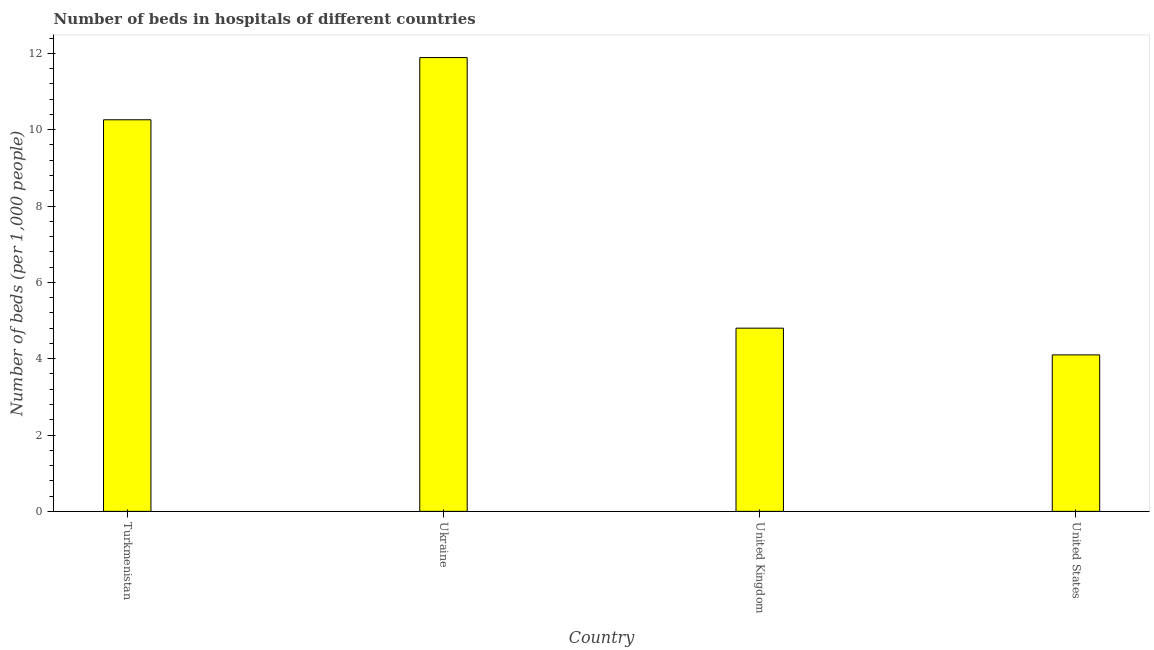Does the graph contain any zero values?
Offer a terse response. No. Does the graph contain grids?
Make the answer very short. No. What is the title of the graph?
Offer a terse response. Number of beds in hospitals of different countries. What is the label or title of the X-axis?
Ensure brevity in your answer.  Country. What is the label or title of the Y-axis?
Offer a very short reply. Number of beds (per 1,0 people). What is the number of hospital beds in United States?
Your answer should be very brief. 4.1. Across all countries, what is the maximum number of hospital beds?
Ensure brevity in your answer.  11.89. Across all countries, what is the minimum number of hospital beds?
Your response must be concise. 4.1. In which country was the number of hospital beds maximum?
Your answer should be compact. Ukraine. In which country was the number of hospital beds minimum?
Your answer should be very brief. United States. What is the sum of the number of hospital beds?
Give a very brief answer. 31.05. What is the difference between the number of hospital beds in Ukraine and United States?
Offer a very short reply. 7.79. What is the average number of hospital beds per country?
Your answer should be compact. 7.76. What is the median number of hospital beds?
Your answer should be compact. 7.53. In how many countries, is the number of hospital beds greater than 10.8 %?
Your answer should be compact. 1. What is the ratio of the number of hospital beds in Ukraine to that in United States?
Your response must be concise. 2.9. Is the difference between the number of hospital beds in United Kingdom and United States greater than the difference between any two countries?
Keep it short and to the point. No. What is the difference between the highest and the second highest number of hospital beds?
Provide a succinct answer. 1.63. What is the difference between the highest and the lowest number of hospital beds?
Ensure brevity in your answer.  7.79. How many bars are there?
Ensure brevity in your answer.  4. Are all the bars in the graph horizontal?
Provide a short and direct response. No. How many countries are there in the graph?
Keep it short and to the point. 4. What is the difference between two consecutive major ticks on the Y-axis?
Make the answer very short. 2. Are the values on the major ticks of Y-axis written in scientific E-notation?
Ensure brevity in your answer.  No. What is the Number of beds (per 1,000 people) in Turkmenistan?
Give a very brief answer. 10.26. What is the Number of beds (per 1,000 people) of Ukraine?
Offer a terse response. 11.89. What is the Number of beds (per 1,000 people) in United Kingdom?
Your response must be concise. 4.8. What is the Number of beds (per 1,000 people) in United States?
Keep it short and to the point. 4.1. What is the difference between the Number of beds (per 1,000 people) in Turkmenistan and Ukraine?
Ensure brevity in your answer.  -1.63. What is the difference between the Number of beds (per 1,000 people) in Turkmenistan and United Kingdom?
Give a very brief answer. 5.46. What is the difference between the Number of beds (per 1,000 people) in Turkmenistan and United States?
Provide a short and direct response. 6.16. What is the difference between the Number of beds (per 1,000 people) in Ukraine and United Kingdom?
Your answer should be very brief. 7.09. What is the difference between the Number of beds (per 1,000 people) in Ukraine and United States?
Offer a very short reply. 7.79. What is the difference between the Number of beds (per 1,000 people) in United Kingdom and United States?
Your response must be concise. 0.7. What is the ratio of the Number of beds (per 1,000 people) in Turkmenistan to that in Ukraine?
Ensure brevity in your answer.  0.86. What is the ratio of the Number of beds (per 1,000 people) in Turkmenistan to that in United Kingdom?
Offer a very short reply. 2.14. What is the ratio of the Number of beds (per 1,000 people) in Turkmenistan to that in United States?
Ensure brevity in your answer.  2.5. What is the ratio of the Number of beds (per 1,000 people) in Ukraine to that in United Kingdom?
Offer a very short reply. 2.48. What is the ratio of the Number of beds (per 1,000 people) in United Kingdom to that in United States?
Ensure brevity in your answer.  1.17. 